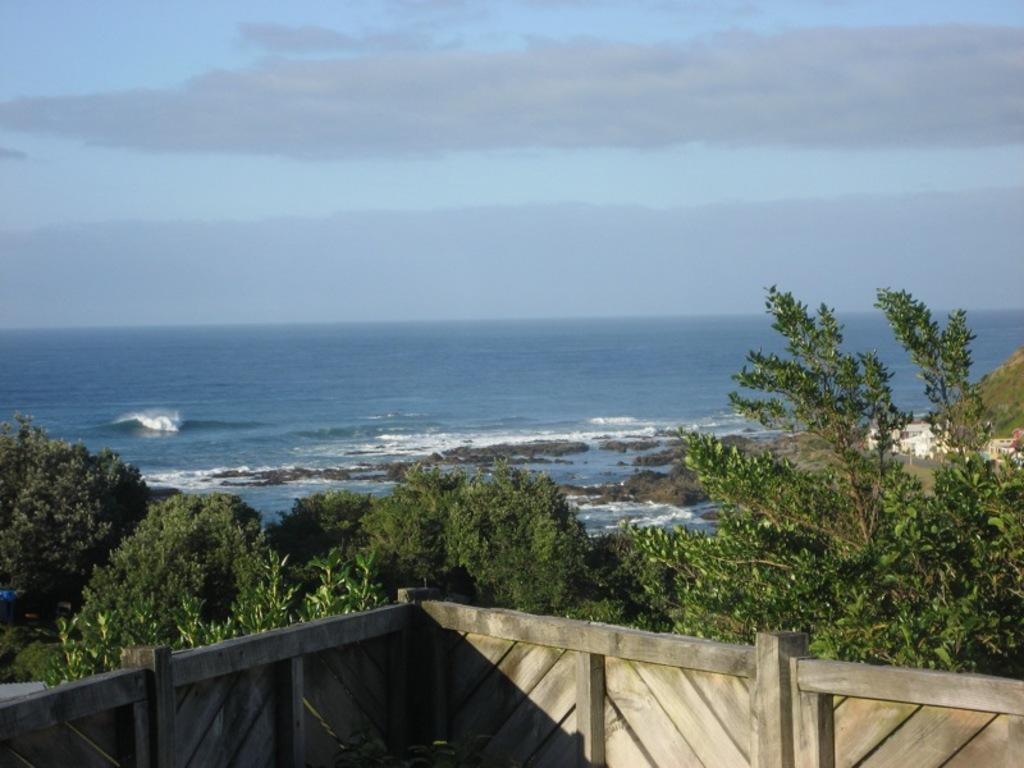What type of natural environment is depicted in the image? The image features many trees, water, rocks, and a wooden railing, suggesting a natural setting. Can you describe the wooden railing in the image? Yes, there is a wooden railing in the image. What is visible in the sky in the image? The sky is visible in the image, and clouds are present. How many elements can be seen in the image? There are six elements visible in the image: trees, water, rocks, a wooden railing, the sky, and clouds. Where is the library located in the image? There is no library present in the image. How much money is visible in the image? There is no money visible in the image. 